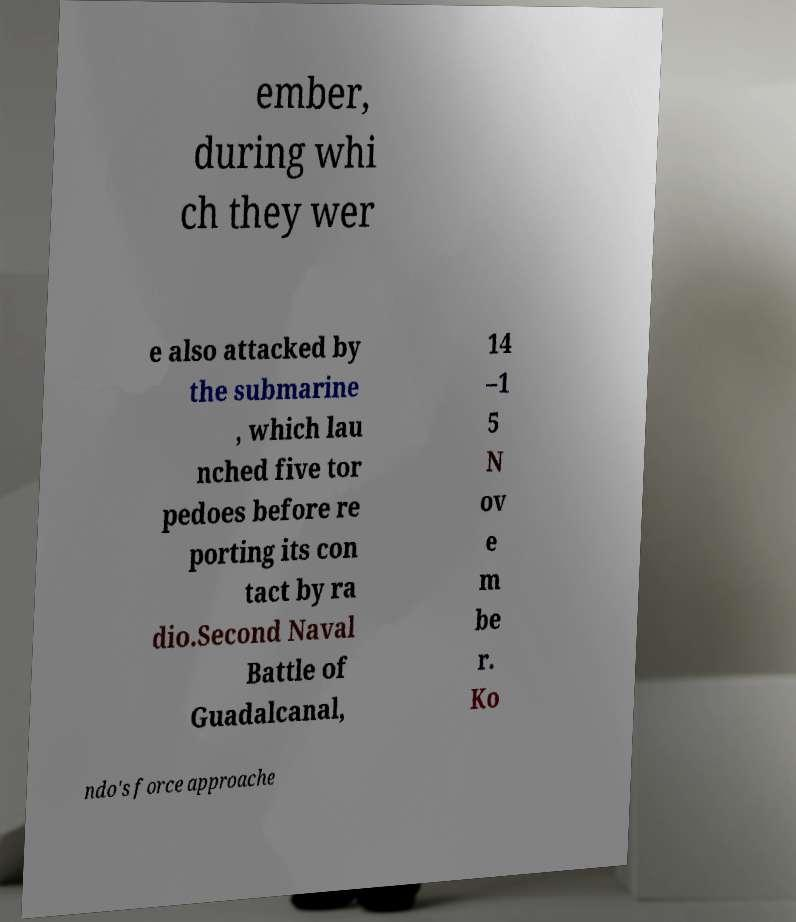What messages or text are displayed in this image? I need them in a readable, typed format. ember, during whi ch they wer e also attacked by the submarine , which lau nched five tor pedoes before re porting its con tact by ra dio.Second Naval Battle of Guadalcanal, 14 –1 5 N ov e m be r. Ko ndo's force approache 